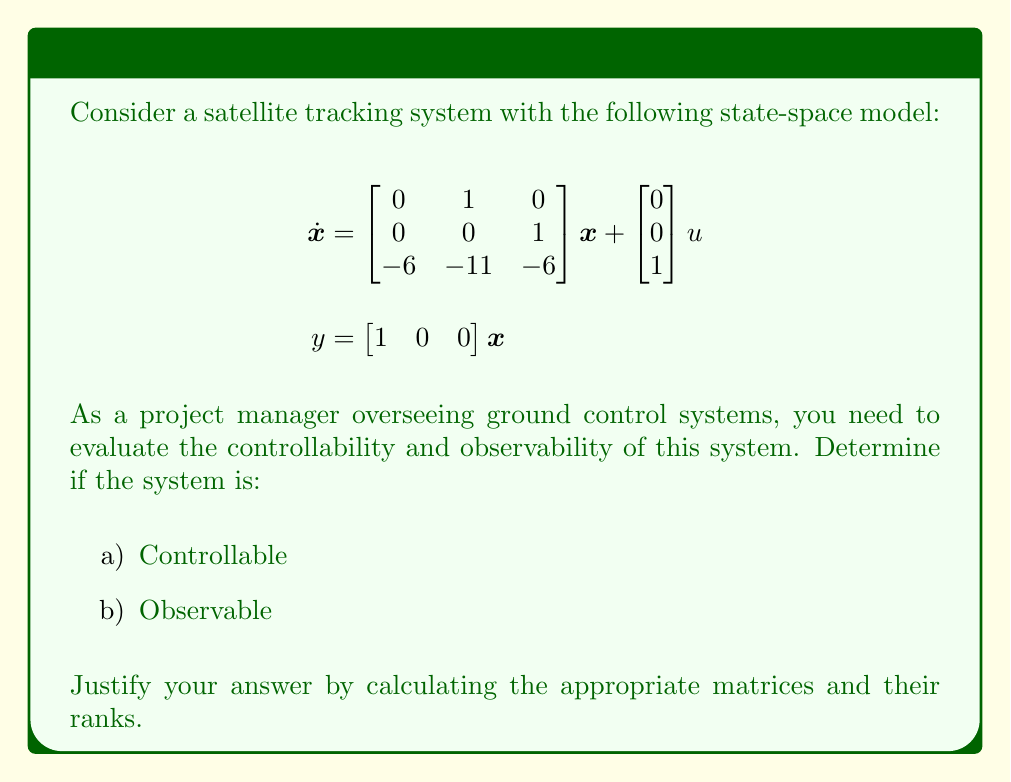Teach me how to tackle this problem. To evaluate the controllability and observability of the given state-space model, we need to calculate the controllability and observability matrices and determine their ranks.

1. Controllability:
The controllability matrix is given by $C = [B \quad AB \quad A^2B]$, where $A$ is the state matrix and $B$ is the input matrix.

$$A = \begin{bmatrix} 0 & 1 & 0 \\ 0 & 0 & 1 \\ -6 & -11 & -6 \end{bmatrix}, \quad B = \begin{bmatrix} 0 \\ 0 \\ 1 \end{bmatrix}$$

Calculate $AB$:
$$AB = \begin{bmatrix} 0 & 1 & 0 \\ 0 & 0 & 1 \\ -6 & -11 & -6 \end{bmatrix} \begin{bmatrix} 0 \\ 0 \\ 1 \end{bmatrix} = \begin{bmatrix} 0 \\ 1 \\ -6 \end{bmatrix}$$

Calculate $A^2B$:
$$A^2B = \begin{bmatrix} 0 & 1 & 0 \\ 0 & 0 & 1 \\ -6 & -11 & -6 \end{bmatrix} \begin{bmatrix} 0 \\ 1 \\ -6 \end{bmatrix} = \begin{bmatrix} 1 \\ -6 \\ -11 \end{bmatrix}$$

Now, form the controllability matrix:
$$C = [B \quad AB \quad A^2B] = \begin{bmatrix} 0 & 0 & 1 \\ 0 & 1 & -6 \\ 1 & -6 & -11 \end{bmatrix}$$

The rank of matrix $C$ is 3, which is equal to the number of states. Therefore, the system is controllable.

2. Observability:
The observability matrix is given by $O = [C^T \quad A^TC^T \quad (A^T)^2C^T]$, where $C$ is the output matrix.

$$C = \begin{bmatrix} 1 & 0 & 0 \end{bmatrix}$$

Calculate $A^TC^T$:
$$A^TC^T = \begin{bmatrix} 0 & 0 & -6 \\ 1 & 0 & -11 \\ 0 & 1 & -6 \end{bmatrix} \begin{bmatrix} 1 \\ 0 \\ 0 \end{bmatrix} = \begin{bmatrix} 0 \\ 1 \\ 0 \end{bmatrix}$$

Calculate $(A^T)^2C^T$:
$$(A^T)^2C^T = \begin{bmatrix} 0 & 0 & -6 \\ 1 & 0 & -11 \\ 0 & 1 & -6 \end{bmatrix} \begin{bmatrix} 0 \\ 1 \\ 0 \end{bmatrix} = \begin{bmatrix} 0 \\ 0 \\ 1 \end{bmatrix}$$

Now, form the observability matrix:
$$O = [C^T \quad A^TC^T \quad (A^T)^2C^T] = \begin{bmatrix} 1 & 0 & 0 \\ 0 & 1 & 0 \\ 0 & 0 & 1 \end{bmatrix}$$

The rank of matrix $O$ is 3, which is equal to the number of states. Therefore, the system is observable.
Answer: The satellite tracking system is:
a) Controllable (rank of controllability matrix = 3)
b) Observable (rank of observability matrix = 3) 